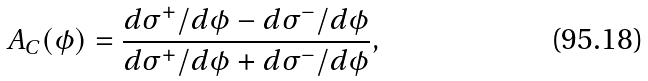Convert formula to latex. <formula><loc_0><loc_0><loc_500><loc_500>A _ { C } ( \phi ) = \frac { d \sigma ^ { + } / d \phi - d \sigma ^ { - } / d \phi } { d \sigma ^ { + } / d \phi + d \sigma ^ { - } / d \phi } ,</formula> 